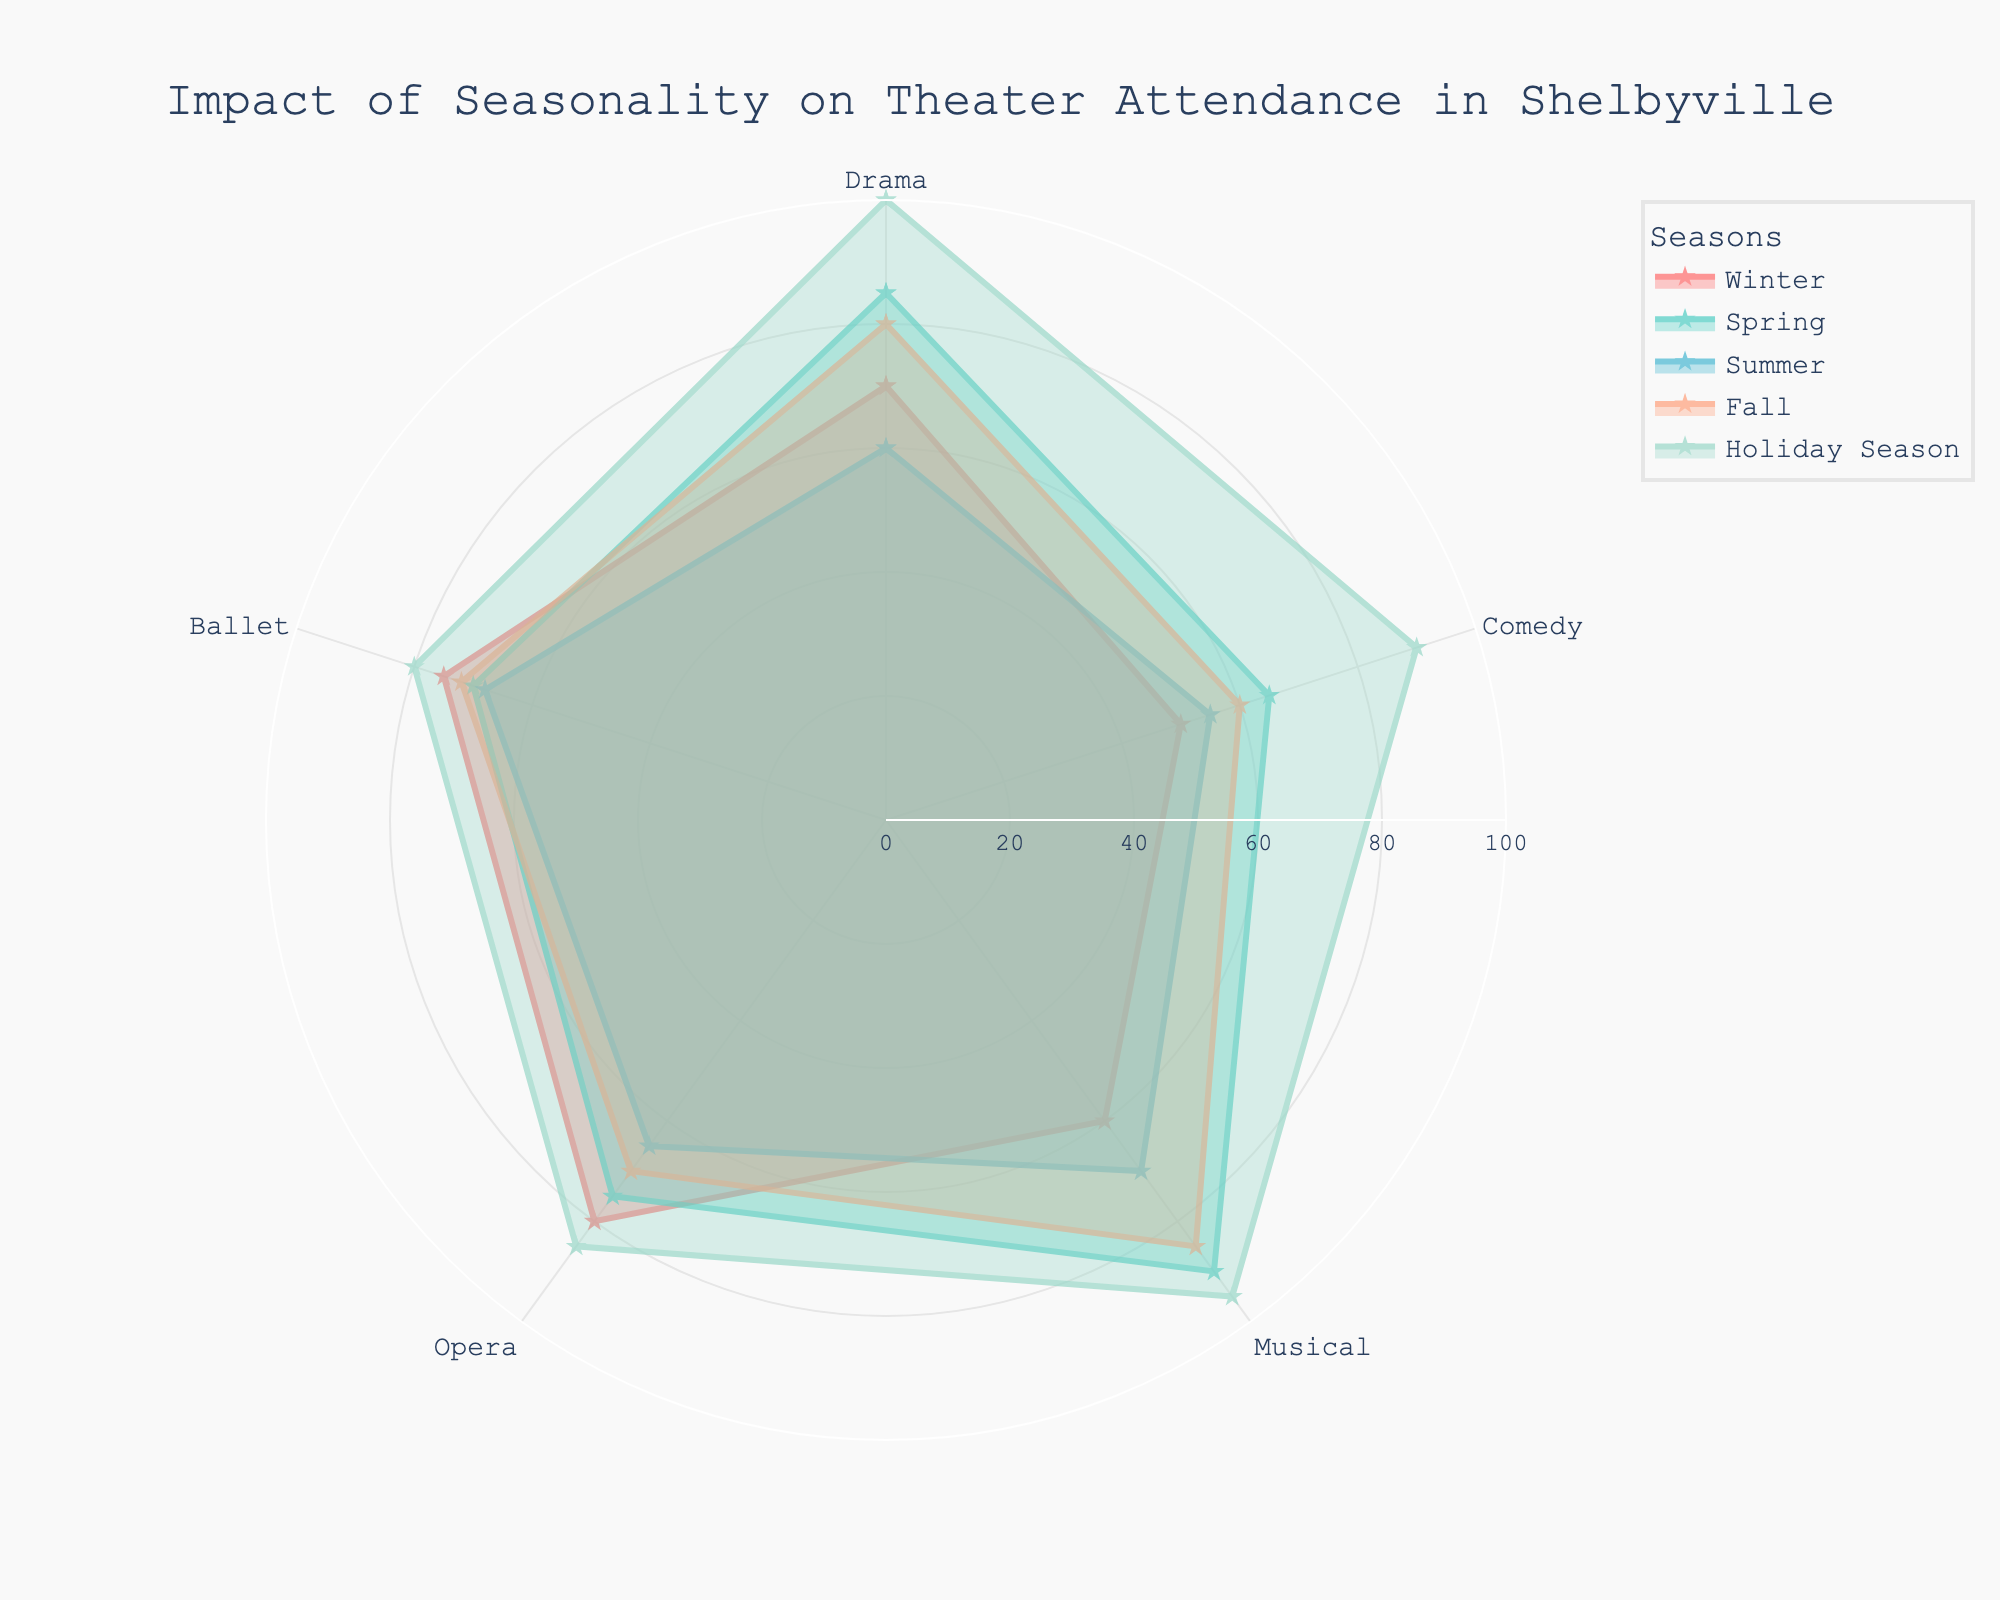what is the dominant color in the plot? The plot uses multiple colors for different seasons, but the dominant colors visible are shades like red, teal, blue, orange, and light green. Red is the most impactful as it represents the Holiday Season.
Answer: Red Which season has the highest attendance for Musical performances? The Musical attendance for each season can be read from the radar chart where the Holiday Season's value reaches the highest point at 95.
Answer: Holiday Season In which season is Drama attendance the lowest? By looking at the radar chart, the Drama attendance is lowest during the Summer, with a value of 60.
Answer: Summer What is the range of Opera attendance across all seasons? The highest Opera attendance is during Winter (80), and the lowest is during Summer (65), so the range is calculated as 80 - 65 = 15.
Answer: 15 Is Ballet attendance higher in Spring or Fall? Comparing the values from the radar chart, Ballet attendance in Spring is 70 and in Fall is 72, therefore it is higher in Fall.
Answer: Fall Which two seasons show the largest difference in Comedy attendance? Comedy attendance is highest in the Holiday Season (90) and lowest in Winter (50). The difference is 90 - 50 = 40.
Answer: Holiday Season and Winter In which season and category do we see a perfect matchup in attendance? By reviewing the radar chart, we see that Drama in Spring and Ballet in Fall both have an attendance of 70. This is the only matchup in the chart.
Answer: Drama in Spring and Ballet in Fall What is the average attendance for all theater types in the Holiday Season? Summing up the values for Holiday Season (100 for Drama, 90 for Comedy, 95 for Musical, 85 for Opera, and 80 for Ballet) gives 450. Dividing by 5 (since there are 5 categories) gives an average of 450/5 = 90.
Answer: 90 Which performance type has the least variation in attendance across all seasons? Looking at the radar chart, Ballet attendance varies between 68 and 80 across all seasons, a difference of 12. This is the least variation among performance types.
Answer: Ballet What's the combined attendance for Operas and Ballets in Winter? The attendance for Operas is 80 and for Ballets is 75. Adding these values gives 80 + 75 = 155.
Answer: 155 